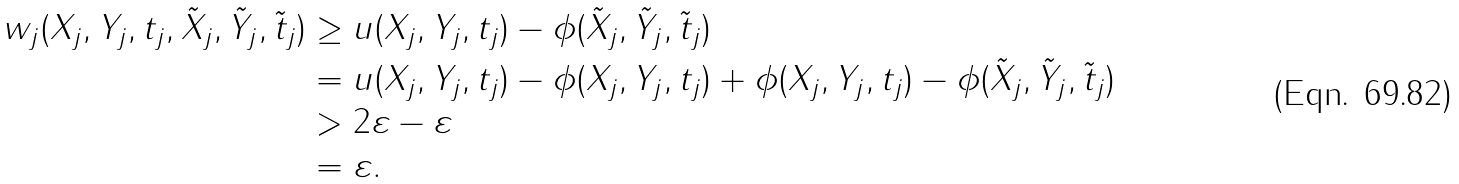<formula> <loc_0><loc_0><loc_500><loc_500>w _ { j } ( X _ { j } , Y _ { j } , t _ { j } , \tilde { X } _ { j } , \tilde { Y } _ { j } , \tilde { t } _ { j } ) & \geq u ( X _ { j } , Y _ { j } , t _ { j } ) - \phi ( \tilde { X } _ { j } , \tilde { Y } _ { j } , \tilde { t } _ { j } ) \\ & = u ( X _ { j } , Y _ { j } , t _ { j } ) - \phi ( X _ { j } , Y _ { j } , t _ { j } ) + \phi ( X _ { j } , Y _ { j } , t _ { j } ) - \phi ( \tilde { X } _ { j } , \tilde { Y } _ { j } , \tilde { t } _ { j } ) \\ & > 2 \varepsilon - \varepsilon \\ & = \varepsilon .</formula> 